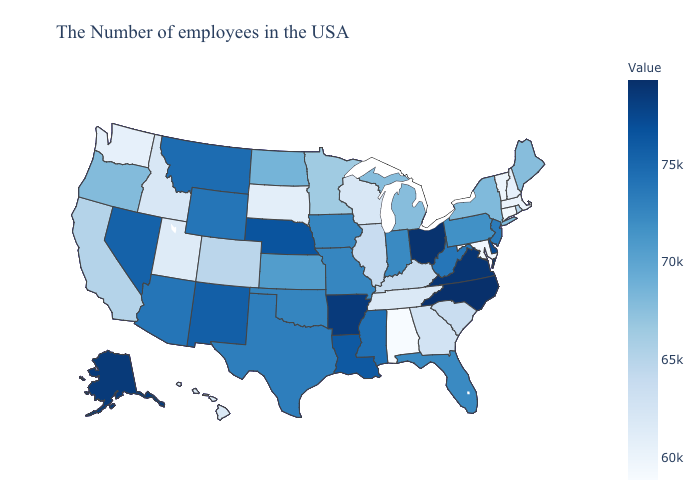Does the map have missing data?
Answer briefly. No. Among the states that border Missouri , which have the lowest value?
Be succinct. Tennessee. Which states have the lowest value in the Northeast?
Quick response, please. Connecticut. Does the map have missing data?
Write a very short answer. No. 